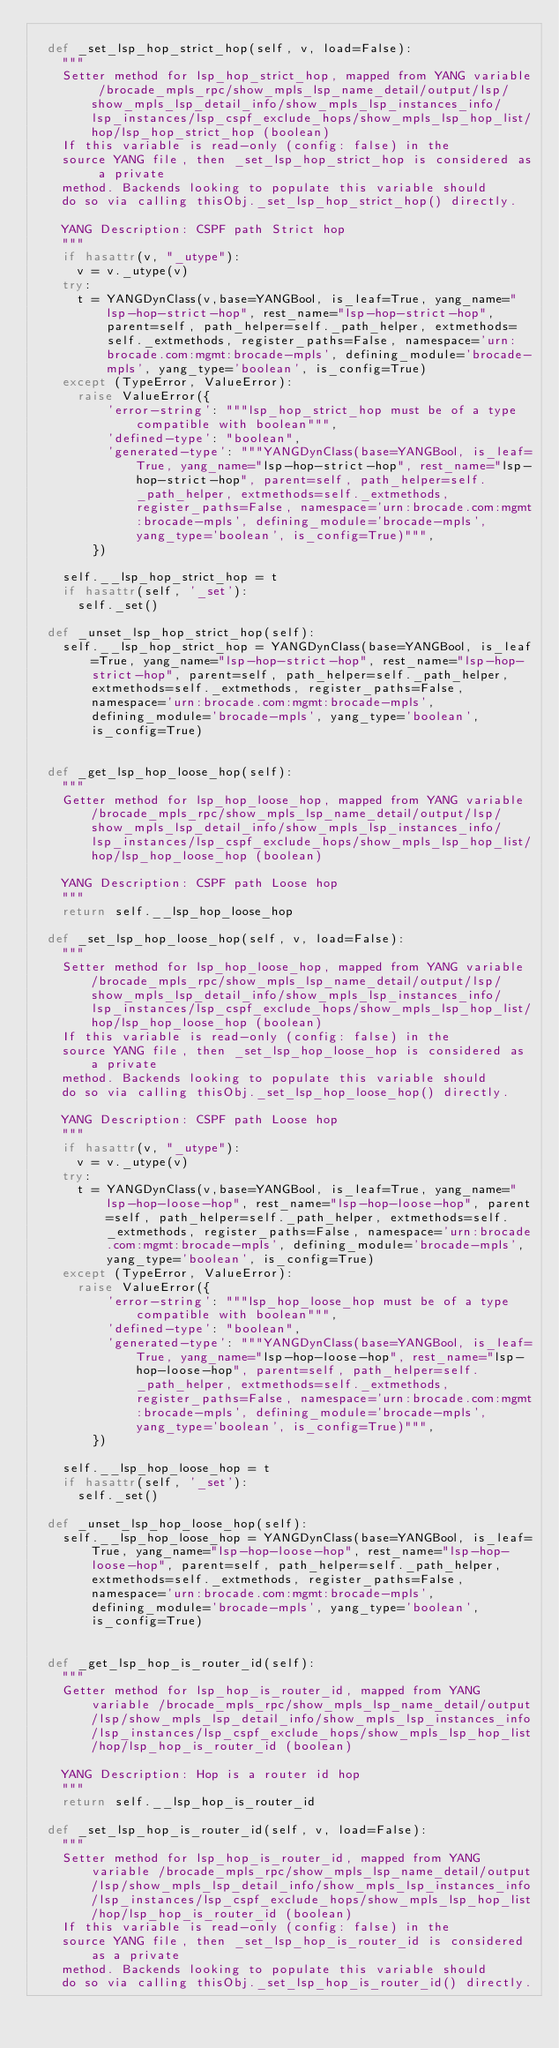Convert code to text. <code><loc_0><loc_0><loc_500><loc_500><_Python_>      
  def _set_lsp_hop_strict_hop(self, v, load=False):
    """
    Setter method for lsp_hop_strict_hop, mapped from YANG variable /brocade_mpls_rpc/show_mpls_lsp_name_detail/output/lsp/show_mpls_lsp_detail_info/show_mpls_lsp_instances_info/lsp_instances/lsp_cspf_exclude_hops/show_mpls_lsp_hop_list/hop/lsp_hop_strict_hop (boolean)
    If this variable is read-only (config: false) in the
    source YANG file, then _set_lsp_hop_strict_hop is considered as a private
    method. Backends looking to populate this variable should
    do so via calling thisObj._set_lsp_hop_strict_hop() directly.

    YANG Description: CSPF path Strict hop
    """
    if hasattr(v, "_utype"):
      v = v._utype(v)
    try:
      t = YANGDynClass(v,base=YANGBool, is_leaf=True, yang_name="lsp-hop-strict-hop", rest_name="lsp-hop-strict-hop", parent=self, path_helper=self._path_helper, extmethods=self._extmethods, register_paths=False, namespace='urn:brocade.com:mgmt:brocade-mpls', defining_module='brocade-mpls', yang_type='boolean', is_config=True)
    except (TypeError, ValueError):
      raise ValueError({
          'error-string': """lsp_hop_strict_hop must be of a type compatible with boolean""",
          'defined-type': "boolean",
          'generated-type': """YANGDynClass(base=YANGBool, is_leaf=True, yang_name="lsp-hop-strict-hop", rest_name="lsp-hop-strict-hop", parent=self, path_helper=self._path_helper, extmethods=self._extmethods, register_paths=False, namespace='urn:brocade.com:mgmt:brocade-mpls', defining_module='brocade-mpls', yang_type='boolean', is_config=True)""",
        })

    self.__lsp_hop_strict_hop = t
    if hasattr(self, '_set'):
      self._set()

  def _unset_lsp_hop_strict_hop(self):
    self.__lsp_hop_strict_hop = YANGDynClass(base=YANGBool, is_leaf=True, yang_name="lsp-hop-strict-hop", rest_name="lsp-hop-strict-hop", parent=self, path_helper=self._path_helper, extmethods=self._extmethods, register_paths=False, namespace='urn:brocade.com:mgmt:brocade-mpls', defining_module='brocade-mpls', yang_type='boolean', is_config=True)


  def _get_lsp_hop_loose_hop(self):
    """
    Getter method for lsp_hop_loose_hop, mapped from YANG variable /brocade_mpls_rpc/show_mpls_lsp_name_detail/output/lsp/show_mpls_lsp_detail_info/show_mpls_lsp_instances_info/lsp_instances/lsp_cspf_exclude_hops/show_mpls_lsp_hop_list/hop/lsp_hop_loose_hop (boolean)

    YANG Description: CSPF path Loose hop
    """
    return self.__lsp_hop_loose_hop
      
  def _set_lsp_hop_loose_hop(self, v, load=False):
    """
    Setter method for lsp_hop_loose_hop, mapped from YANG variable /brocade_mpls_rpc/show_mpls_lsp_name_detail/output/lsp/show_mpls_lsp_detail_info/show_mpls_lsp_instances_info/lsp_instances/lsp_cspf_exclude_hops/show_mpls_lsp_hop_list/hop/lsp_hop_loose_hop (boolean)
    If this variable is read-only (config: false) in the
    source YANG file, then _set_lsp_hop_loose_hop is considered as a private
    method. Backends looking to populate this variable should
    do so via calling thisObj._set_lsp_hop_loose_hop() directly.

    YANG Description: CSPF path Loose hop
    """
    if hasattr(v, "_utype"):
      v = v._utype(v)
    try:
      t = YANGDynClass(v,base=YANGBool, is_leaf=True, yang_name="lsp-hop-loose-hop", rest_name="lsp-hop-loose-hop", parent=self, path_helper=self._path_helper, extmethods=self._extmethods, register_paths=False, namespace='urn:brocade.com:mgmt:brocade-mpls', defining_module='brocade-mpls', yang_type='boolean', is_config=True)
    except (TypeError, ValueError):
      raise ValueError({
          'error-string': """lsp_hop_loose_hop must be of a type compatible with boolean""",
          'defined-type': "boolean",
          'generated-type': """YANGDynClass(base=YANGBool, is_leaf=True, yang_name="lsp-hop-loose-hop", rest_name="lsp-hop-loose-hop", parent=self, path_helper=self._path_helper, extmethods=self._extmethods, register_paths=False, namespace='urn:brocade.com:mgmt:brocade-mpls', defining_module='brocade-mpls', yang_type='boolean', is_config=True)""",
        })

    self.__lsp_hop_loose_hop = t
    if hasattr(self, '_set'):
      self._set()

  def _unset_lsp_hop_loose_hop(self):
    self.__lsp_hop_loose_hop = YANGDynClass(base=YANGBool, is_leaf=True, yang_name="lsp-hop-loose-hop", rest_name="lsp-hop-loose-hop", parent=self, path_helper=self._path_helper, extmethods=self._extmethods, register_paths=False, namespace='urn:brocade.com:mgmt:brocade-mpls', defining_module='brocade-mpls', yang_type='boolean', is_config=True)


  def _get_lsp_hop_is_router_id(self):
    """
    Getter method for lsp_hop_is_router_id, mapped from YANG variable /brocade_mpls_rpc/show_mpls_lsp_name_detail/output/lsp/show_mpls_lsp_detail_info/show_mpls_lsp_instances_info/lsp_instances/lsp_cspf_exclude_hops/show_mpls_lsp_hop_list/hop/lsp_hop_is_router_id (boolean)

    YANG Description: Hop is a router id hop
    """
    return self.__lsp_hop_is_router_id
      
  def _set_lsp_hop_is_router_id(self, v, load=False):
    """
    Setter method for lsp_hop_is_router_id, mapped from YANG variable /brocade_mpls_rpc/show_mpls_lsp_name_detail/output/lsp/show_mpls_lsp_detail_info/show_mpls_lsp_instances_info/lsp_instances/lsp_cspf_exclude_hops/show_mpls_lsp_hop_list/hop/lsp_hop_is_router_id (boolean)
    If this variable is read-only (config: false) in the
    source YANG file, then _set_lsp_hop_is_router_id is considered as a private
    method. Backends looking to populate this variable should
    do so via calling thisObj._set_lsp_hop_is_router_id() directly.
</code> 